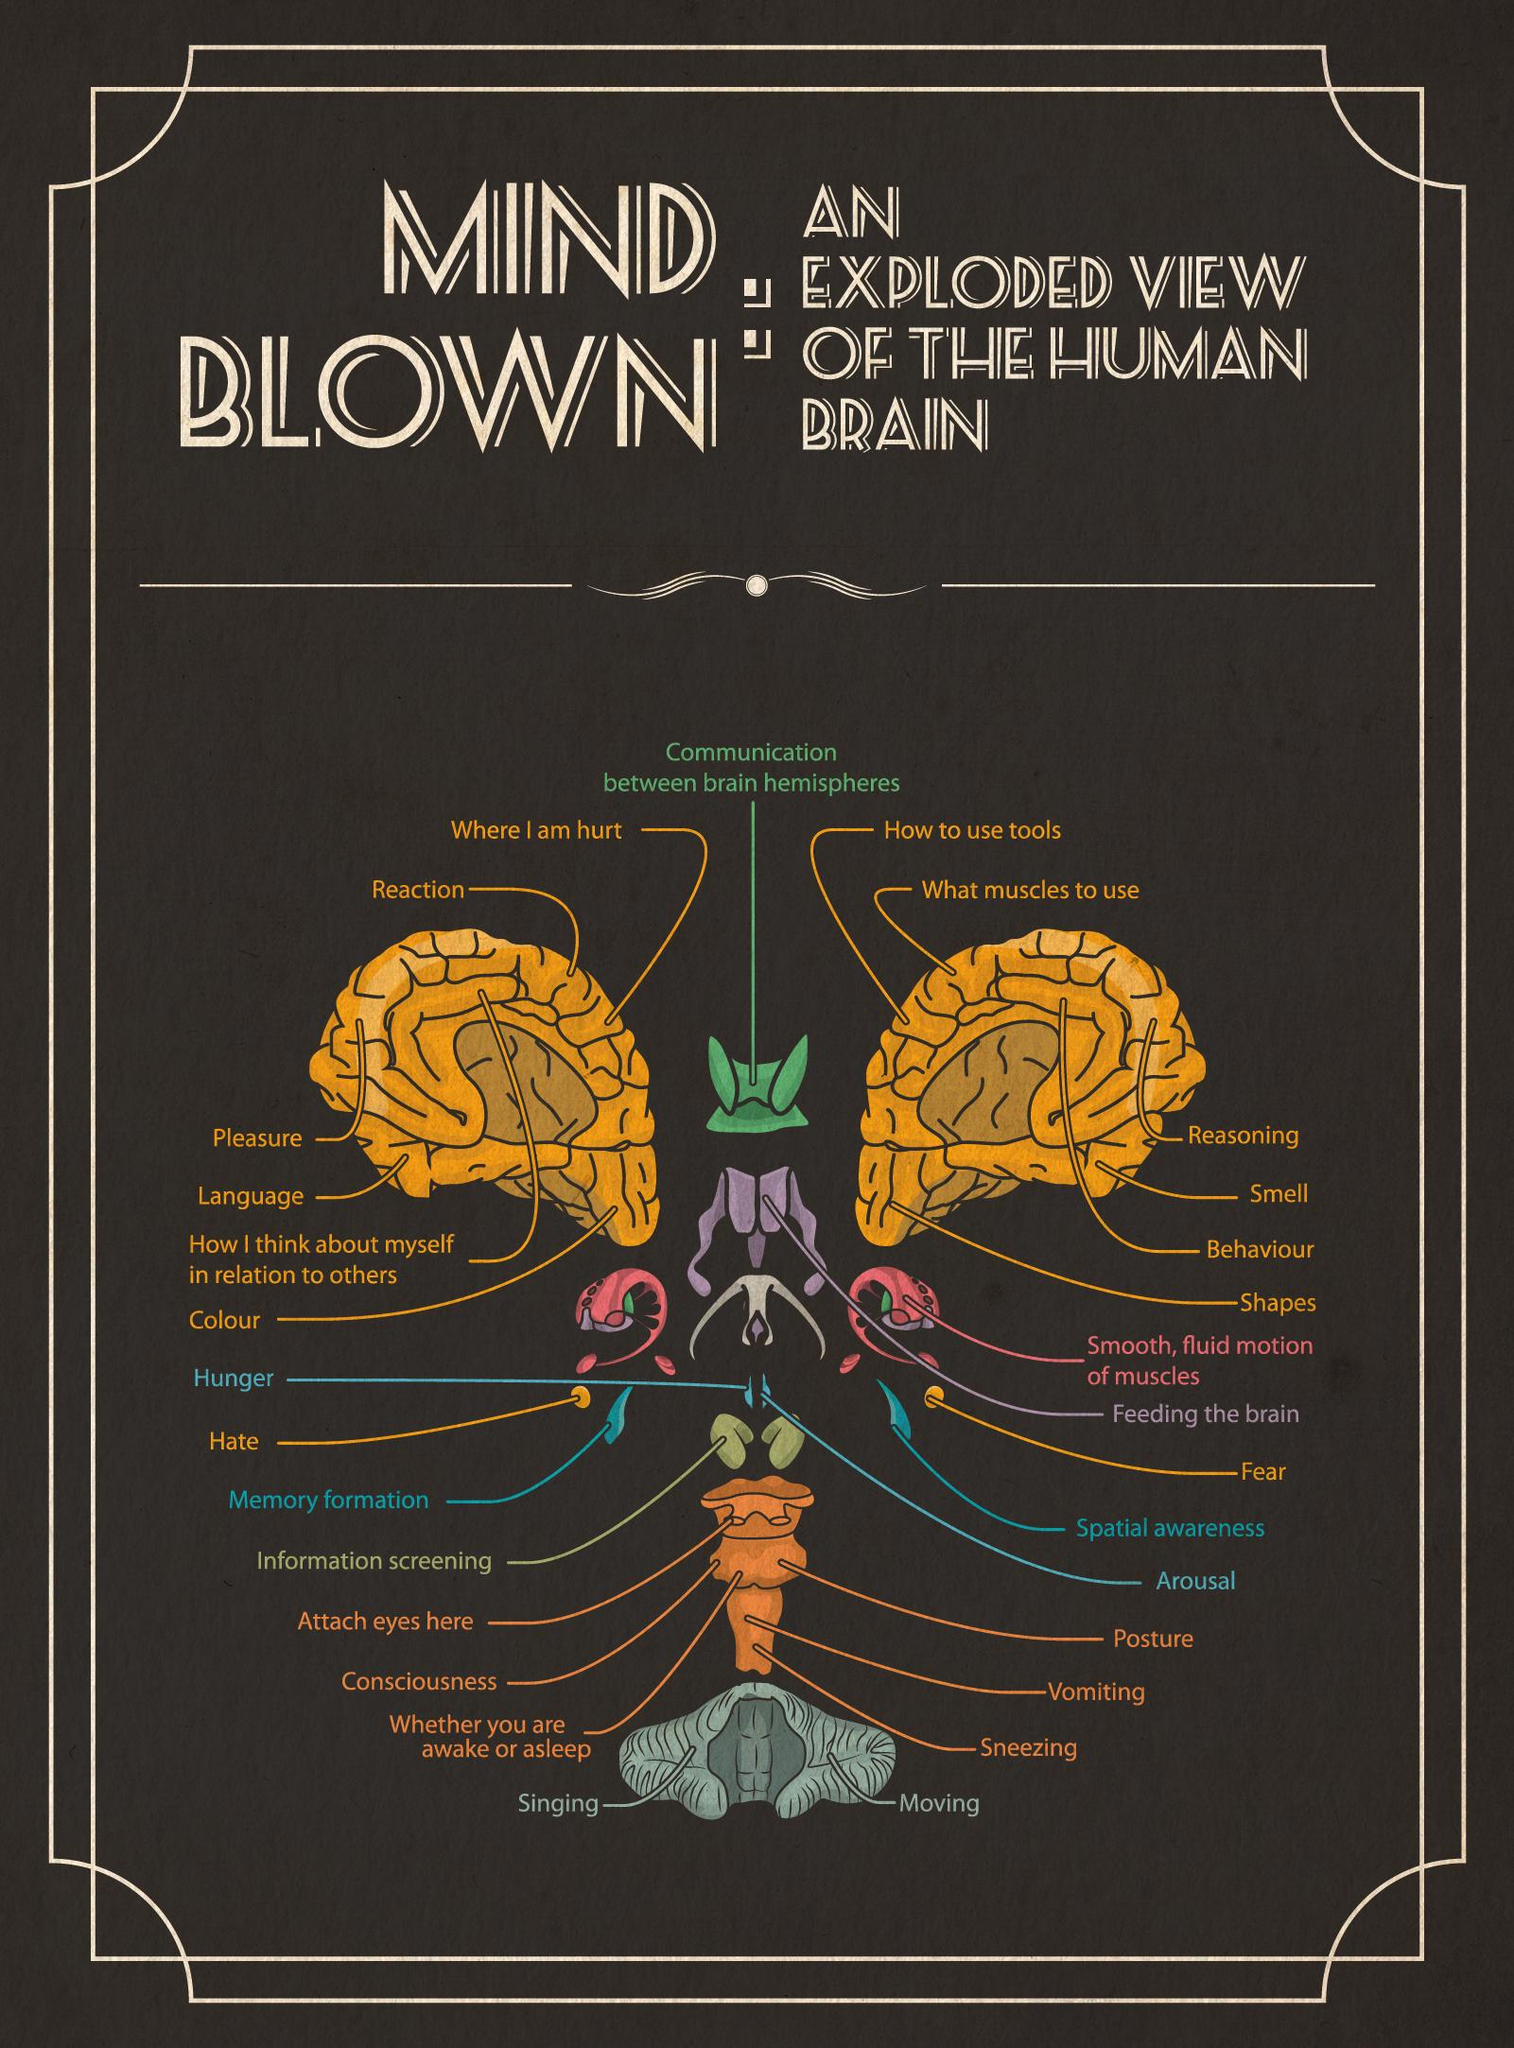Identify some key points in this picture. The part of the brain known as "Reaction" is highlighted in the color yellow. There are 30 items marked in the picture. 